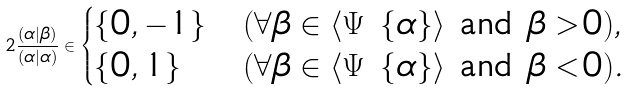Convert formula to latex. <formula><loc_0><loc_0><loc_500><loc_500>2 \frac { ( \alpha | \beta ) } { ( \alpha | \alpha ) } \in \begin{cases} \{ 0 , - 1 \} & ( \forall \beta \in \langle \Psi \ \{ \alpha \} \rangle \text { and } \beta > 0 ) , \\ \{ 0 , 1 \} & ( \forall \beta \in \langle \Psi \ \{ \alpha \} \rangle \text { and } \beta < 0 ) . \end{cases}</formula> 